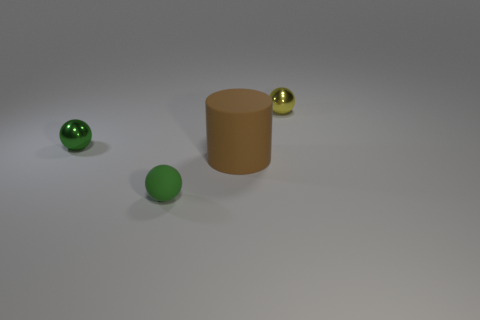Add 3 metal spheres. How many objects exist? 7 Subtract all balls. How many objects are left? 1 Subtract 0 purple cubes. How many objects are left? 4 Subtract all yellow cylinders. Subtract all tiny matte spheres. How many objects are left? 3 Add 2 big matte cylinders. How many big matte cylinders are left? 3 Add 4 big brown objects. How many big brown objects exist? 5 